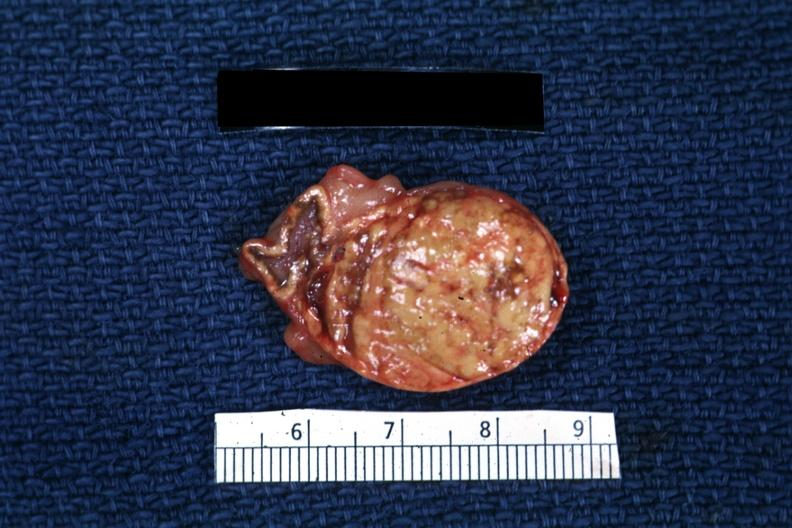s adrenal present?
Answer the question using a single word or phrase. Yes 